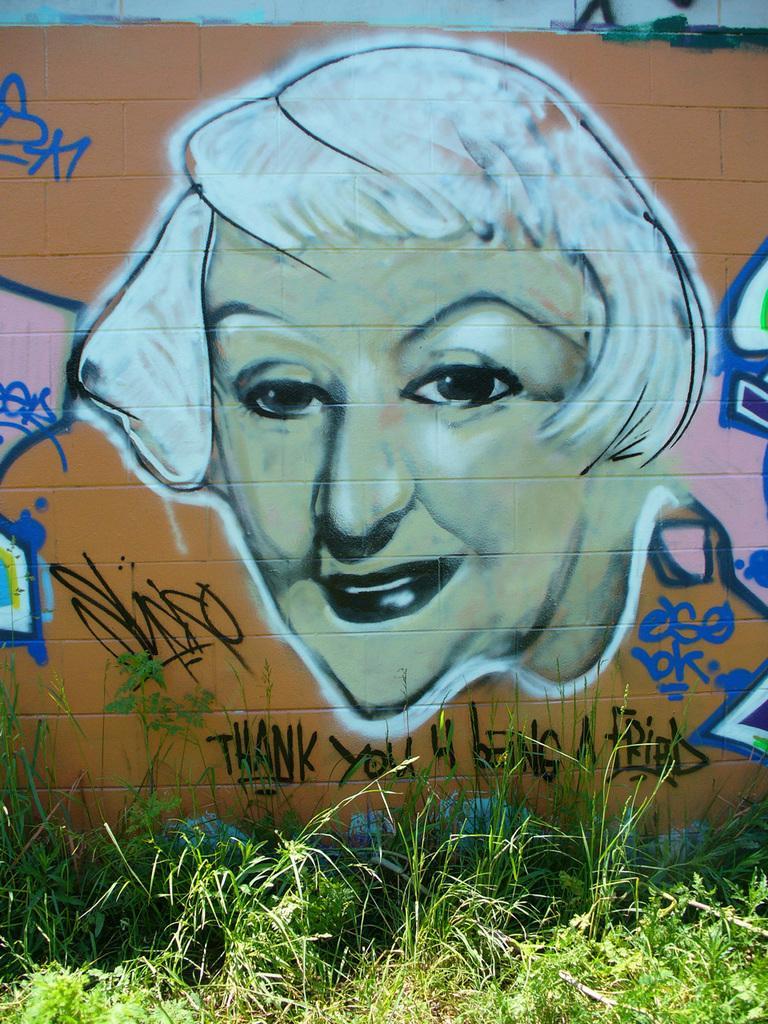How would you summarize this image in a sentence or two? In this image there is a wall. There is a painting of a face of a person on the wall. Below the painting there is text on the wall. At the bottom there are plants and grass on the ground. 